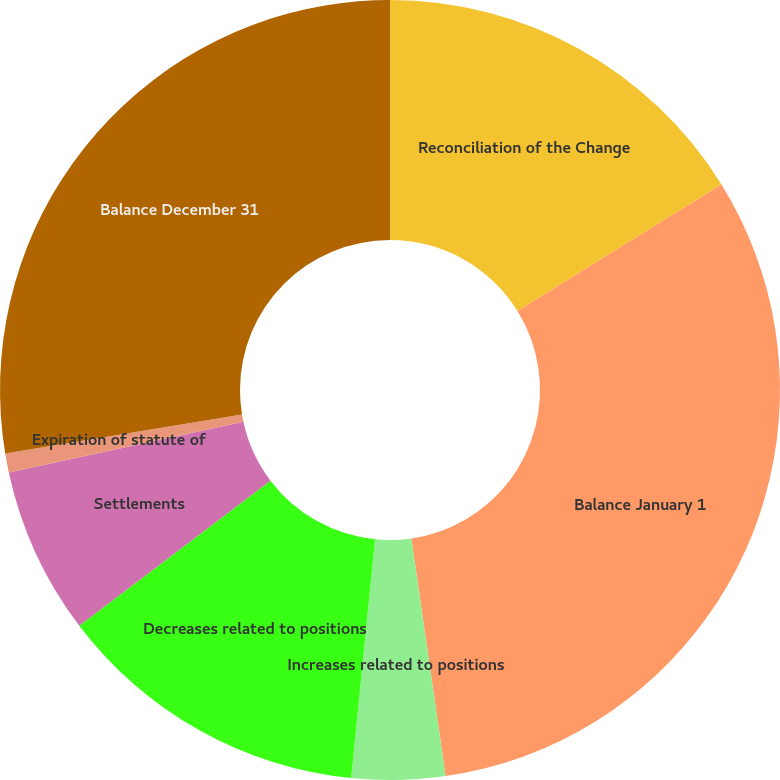Convert chart to OTSL. <chart><loc_0><loc_0><loc_500><loc_500><pie_chart><fcel>Reconciliation of the Change<fcel>Balance January 1<fcel>Increases related to positions<fcel>Decreases related to positions<fcel>Settlements<fcel>Expiration of statute of<fcel>Balance December 31<nl><fcel>16.17%<fcel>31.56%<fcel>3.86%<fcel>13.09%<fcel>6.94%<fcel>0.78%<fcel>27.61%<nl></chart> 